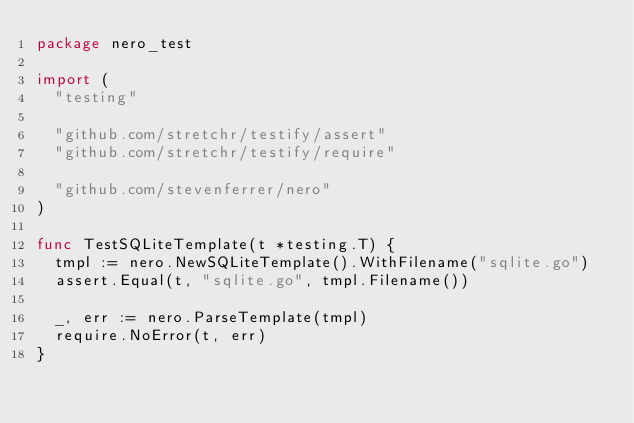Convert code to text. <code><loc_0><loc_0><loc_500><loc_500><_Go_>package nero_test

import (
	"testing"

	"github.com/stretchr/testify/assert"
	"github.com/stretchr/testify/require"

	"github.com/stevenferrer/nero"
)

func TestSQLiteTemplate(t *testing.T) {
	tmpl := nero.NewSQLiteTemplate().WithFilename("sqlite.go")
	assert.Equal(t, "sqlite.go", tmpl.Filename())

	_, err := nero.ParseTemplate(tmpl)
	require.NoError(t, err)
}
</code> 